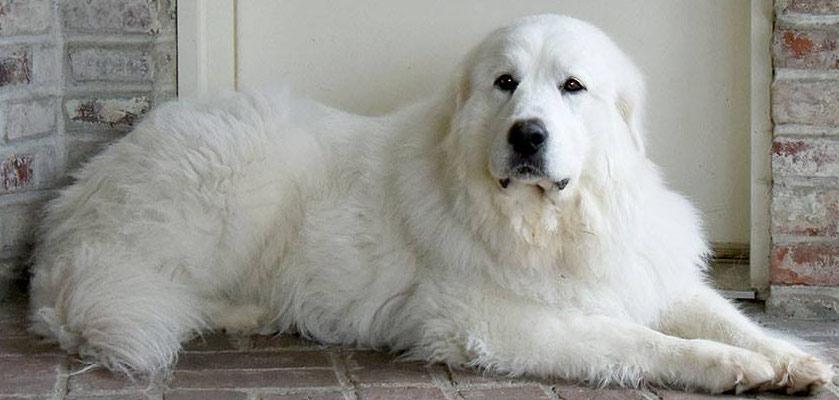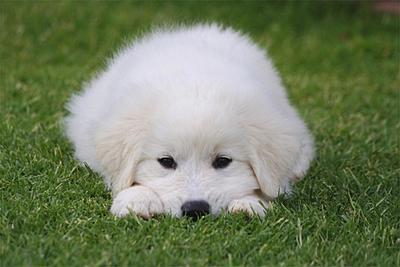The first image is the image on the left, the second image is the image on the right. Given the left and right images, does the statement "A full sized dog is sitting with its legs extended on the ground" hold true? Answer yes or no. Yes. 